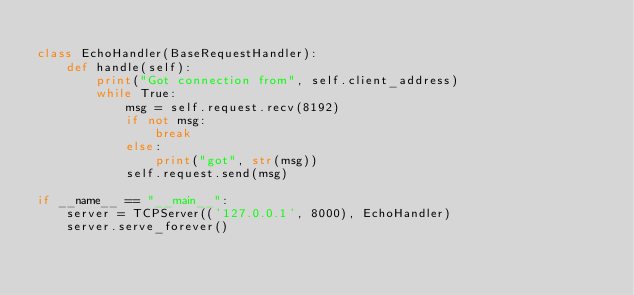<code> <loc_0><loc_0><loc_500><loc_500><_Python_>
class EchoHandler(BaseRequestHandler):
    def handle(self):
        print("Got connection from", self.client_address)
        while True:
            msg = self.request.recv(8192)
            if not msg:
                break
            else:
                print("got", str(msg))
            self.request.send(msg)

if __name__ == "__main__":
    server = TCPServer(('127.0.0.1', 8000), EchoHandler)
    server.serve_forever()</code> 